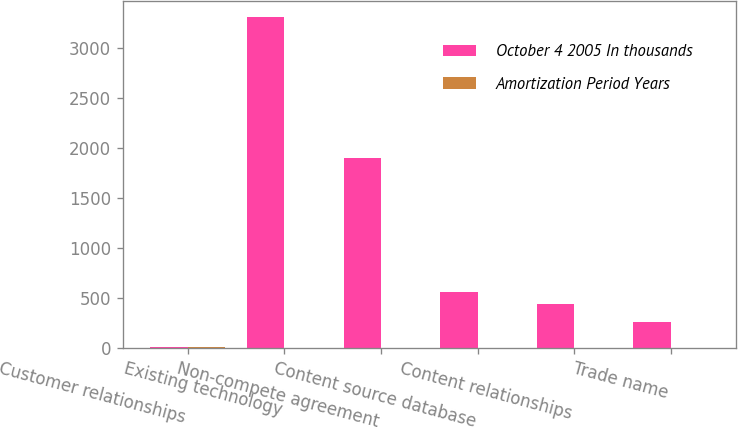Convert chart to OTSL. <chart><loc_0><loc_0><loc_500><loc_500><stacked_bar_chart><ecel><fcel>Customer relationships<fcel>Existing technology<fcel>Non-compete agreement<fcel>Content source database<fcel>Content relationships<fcel>Trade name<nl><fcel>October 4 2005 In thousands<fcel>9<fcel>3300<fcel>1900<fcel>560<fcel>440<fcel>260<nl><fcel>Amortization Period Years<fcel>9<fcel>4<fcel>2<fcel>5<fcel>5<fcel>1<nl></chart> 